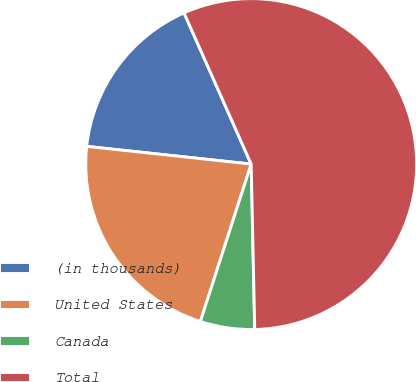Convert chart to OTSL. <chart><loc_0><loc_0><loc_500><loc_500><pie_chart><fcel>(in thousands)<fcel>United States<fcel>Canada<fcel>Total<nl><fcel>16.64%<fcel>21.74%<fcel>5.31%<fcel>56.31%<nl></chart> 